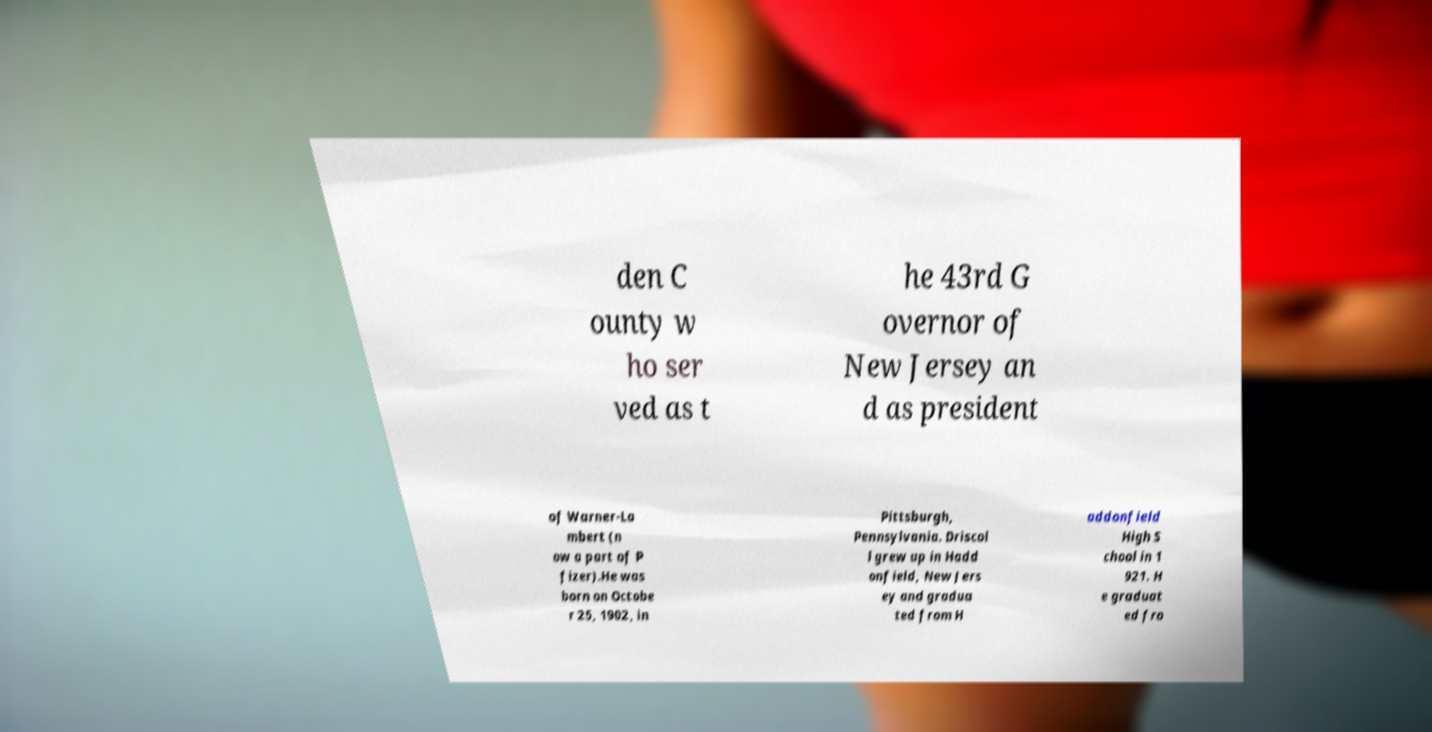I need the written content from this picture converted into text. Can you do that? den C ounty w ho ser ved as t he 43rd G overnor of New Jersey an d as president of Warner-La mbert (n ow a part of P fizer).He was born on Octobe r 25, 1902, in Pittsburgh, Pennsylvania. Driscol l grew up in Hadd onfield, New Jers ey and gradua ted from H addonfield High S chool in 1 921. H e graduat ed fro 